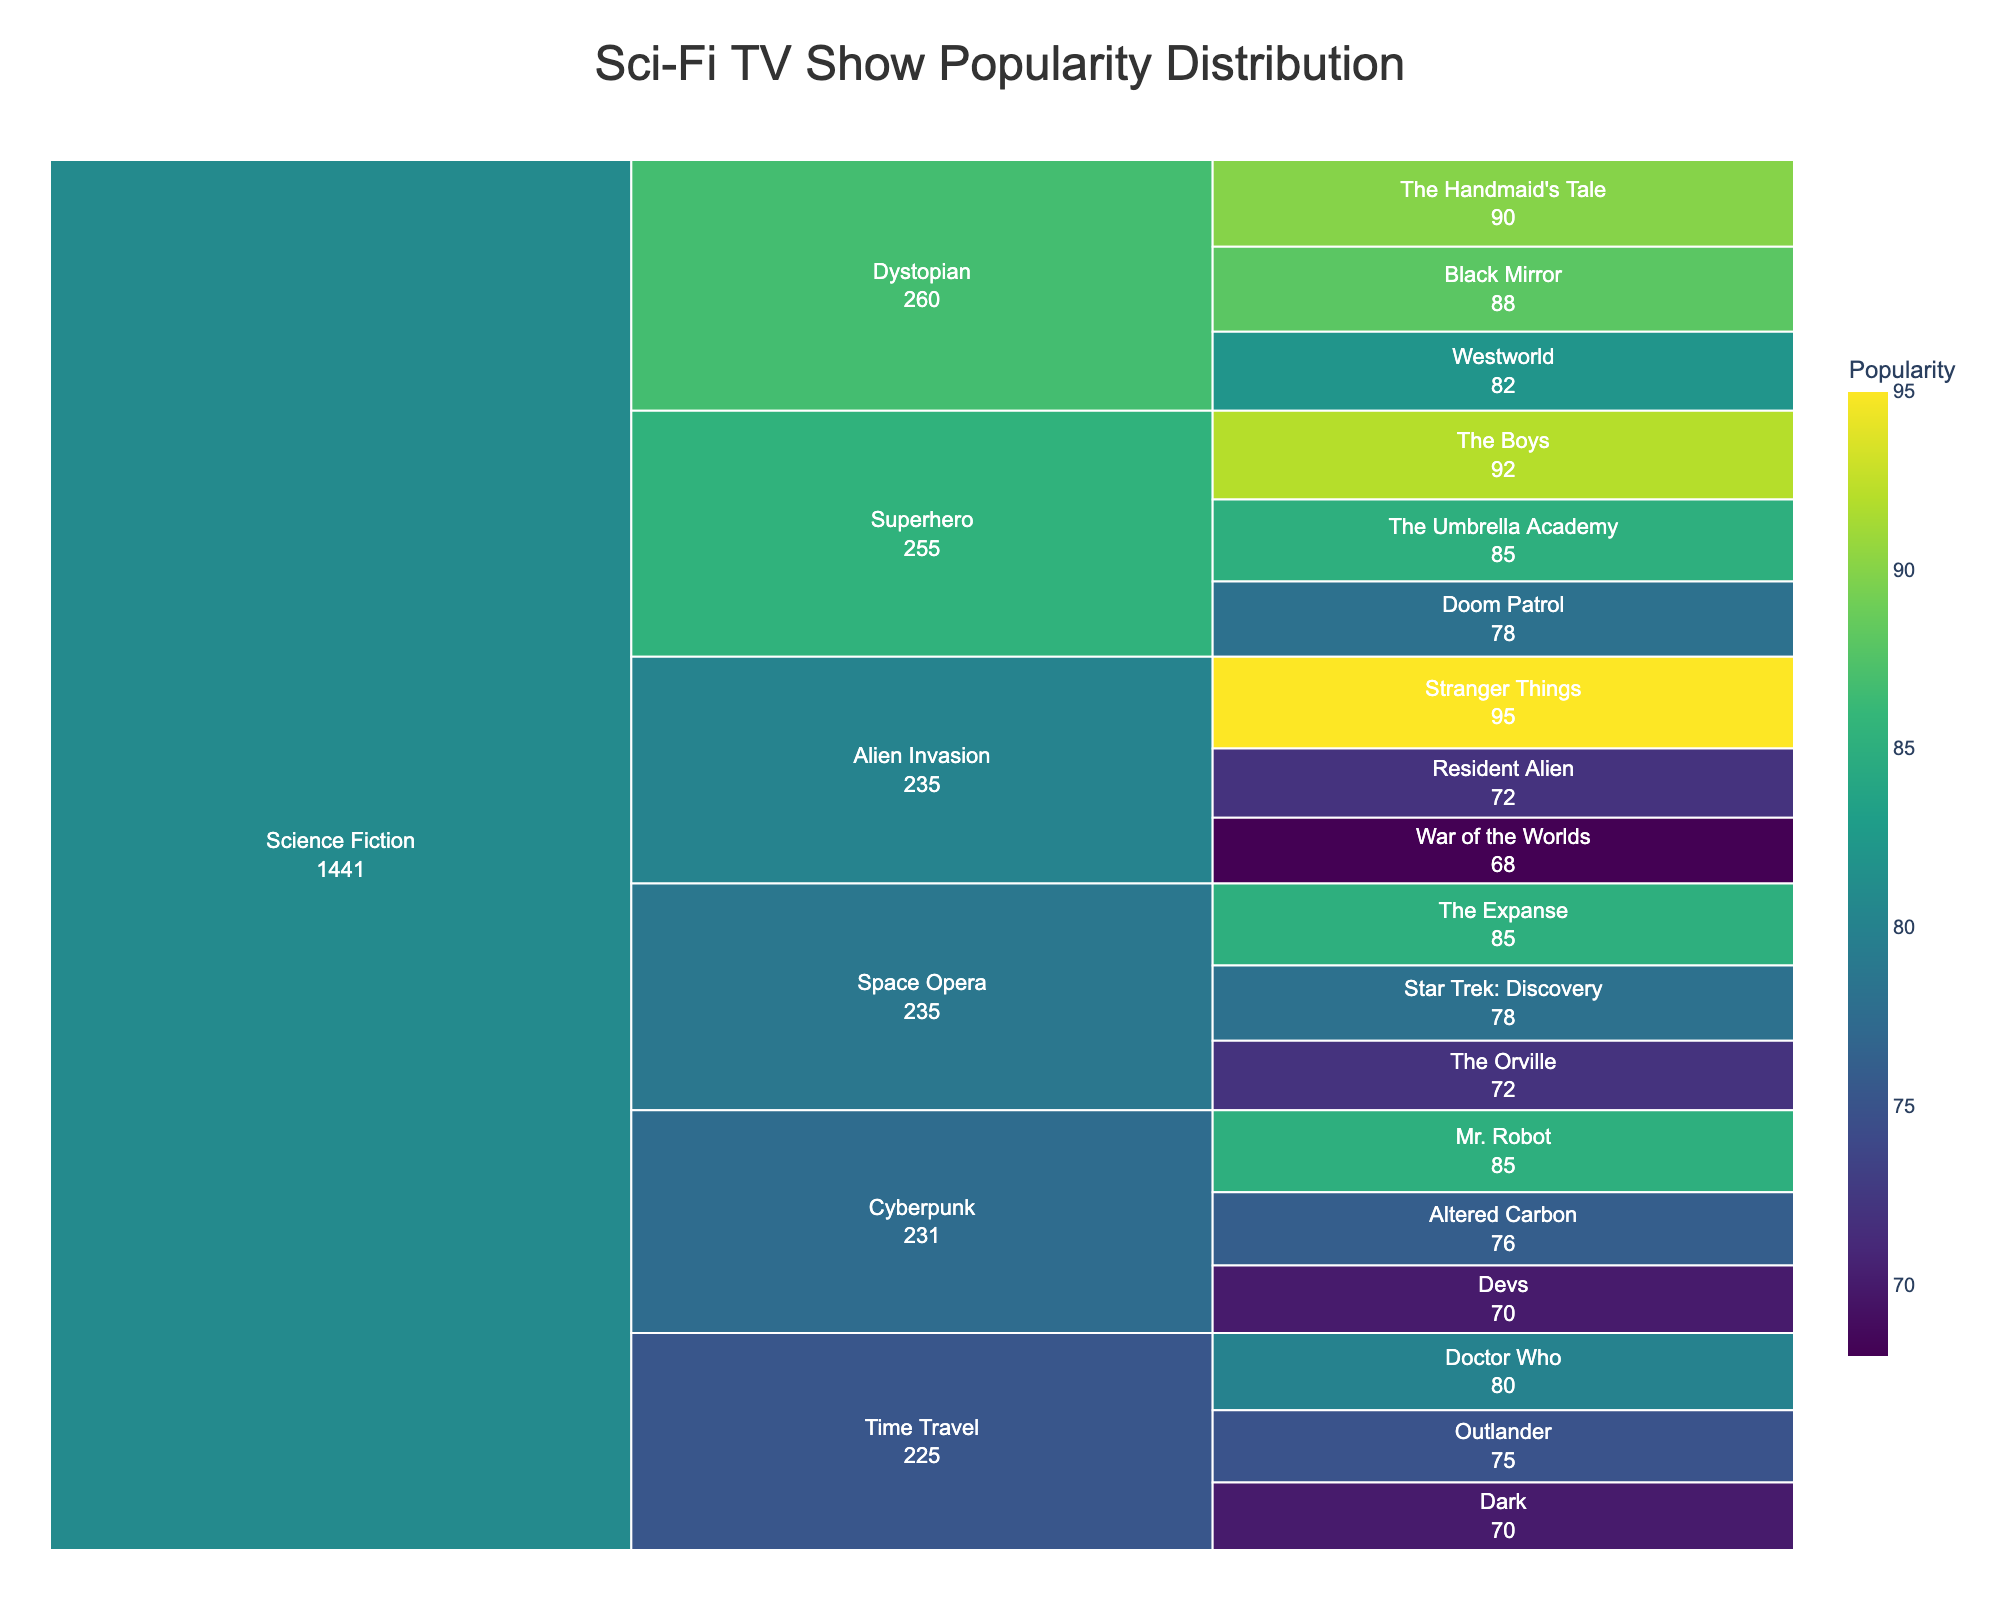What's the title of the icicle chart? The title is situated at the top of the chart, which provides an overview of the content being visualized. In this case, it is about the popularity distribution of Sci-Fi TV shows.
Answer: Sci-Fi TV Show Popularity Distribution Which show has the highest popularity? By analyzing the icicle chart, we can identify the show with the highest popularity based on the numerical values displayed.
Answer: Stranger Things How many Space Opera shows are listed in the chart? Locate the 'Space Opera' category in the chart and count the number of individual shows under this subgenre.
Answer: 3 What is the average popularity of the Superhero shows? To find the average popularity, we need to sum the popularity values of 'The Boys', 'The Umbrella Academy', and 'Doom Patrol' and divide by 3. (92 + 85 + 78) / 3 = 85
Answer: 85 Which subgenre has the lowest maximum popularity value? Compare the highest popularity values within each subgenre category and determine which one is the lowest. 'Alien Invasion' has Stranger Things with a popularity of 95, 'Superhero' has The Boys with 92, etc. 'Alien Invasion' has the lowest max value, which is War of the Worlds at 68.
Answer: Alien Invasion What is the combined popularity of the Dystopian shows? Sum up the popularity values for 'The Handmaid's Tale', 'Black Mirror', and 'Westworld'. (90 + 88 + 82) = 260
Answer: 260 Is there a show with a popularity of 85? If yes, which one(s)? By examining the chart, we can identify any show with a popularity value of 85. There may be multiple instances.
Answer: Yes, 'The Expanse', 'Mr. Robot', and 'The Umbrella Academy' Which subgenre has the largest range in the popularity of its shows? The range is calculated as the difference between the highest and lowest popularity values in each subgenre. Compare these values: for 'Space Opera' (85 - 72 = 13), 'Dystopian' (90 - 82 = 8), etc. 'Alien Invasion' has the largest range (95 - 68 = 27).
Answer: Alien Invasion How does the popularity of 'Westworld' compare to 'Dark'? Observe the popularity values of both 'Westworld' and 'Dark' and compare directly. 'Westworld' has a popularity of 82, while 'Dark' has 70.
Answer: Westworld is more popular than Dark In the Time Travel subgenre, which show is the least popular? Within the Time Travel subgenre category, identify the show with the smallest numerical value for popularity.
Answer: Dark 